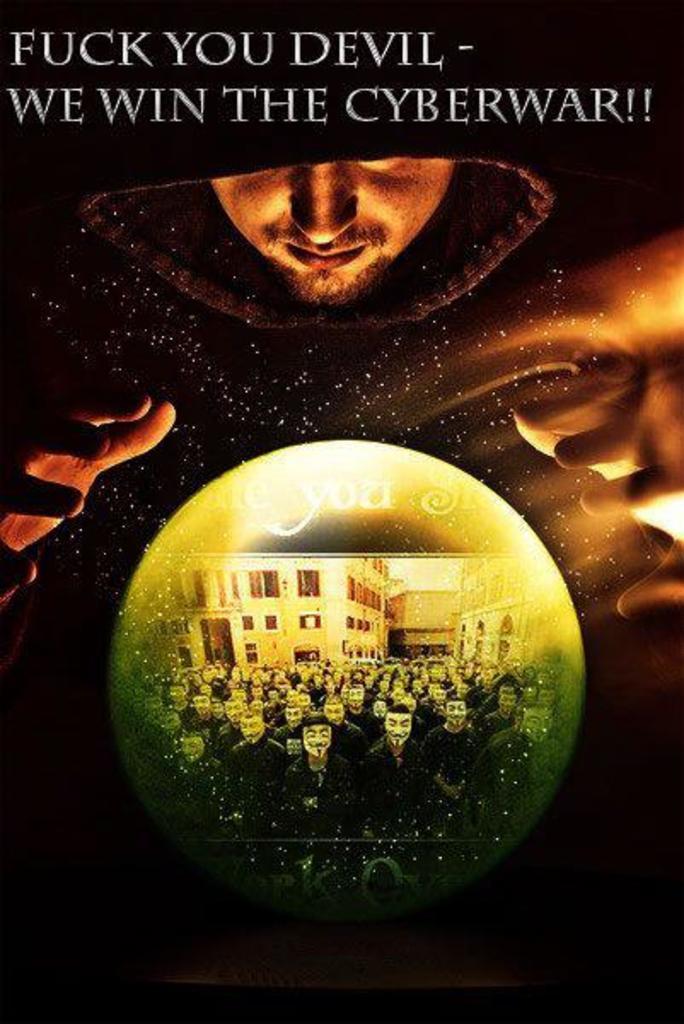What war do they win?
Give a very brief answer. Cyberwar. What war was this?
Offer a very short reply. Cyberwar. 